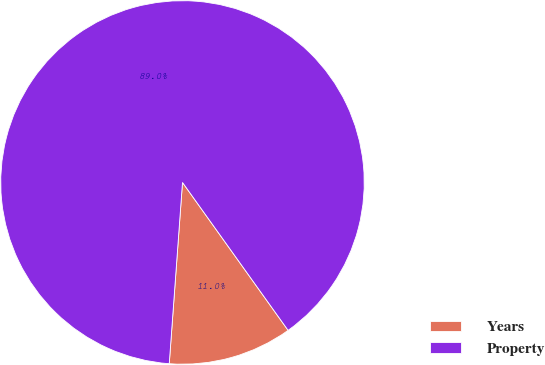<chart> <loc_0><loc_0><loc_500><loc_500><pie_chart><fcel>Years<fcel>Property<nl><fcel>11.03%<fcel>88.97%<nl></chart> 